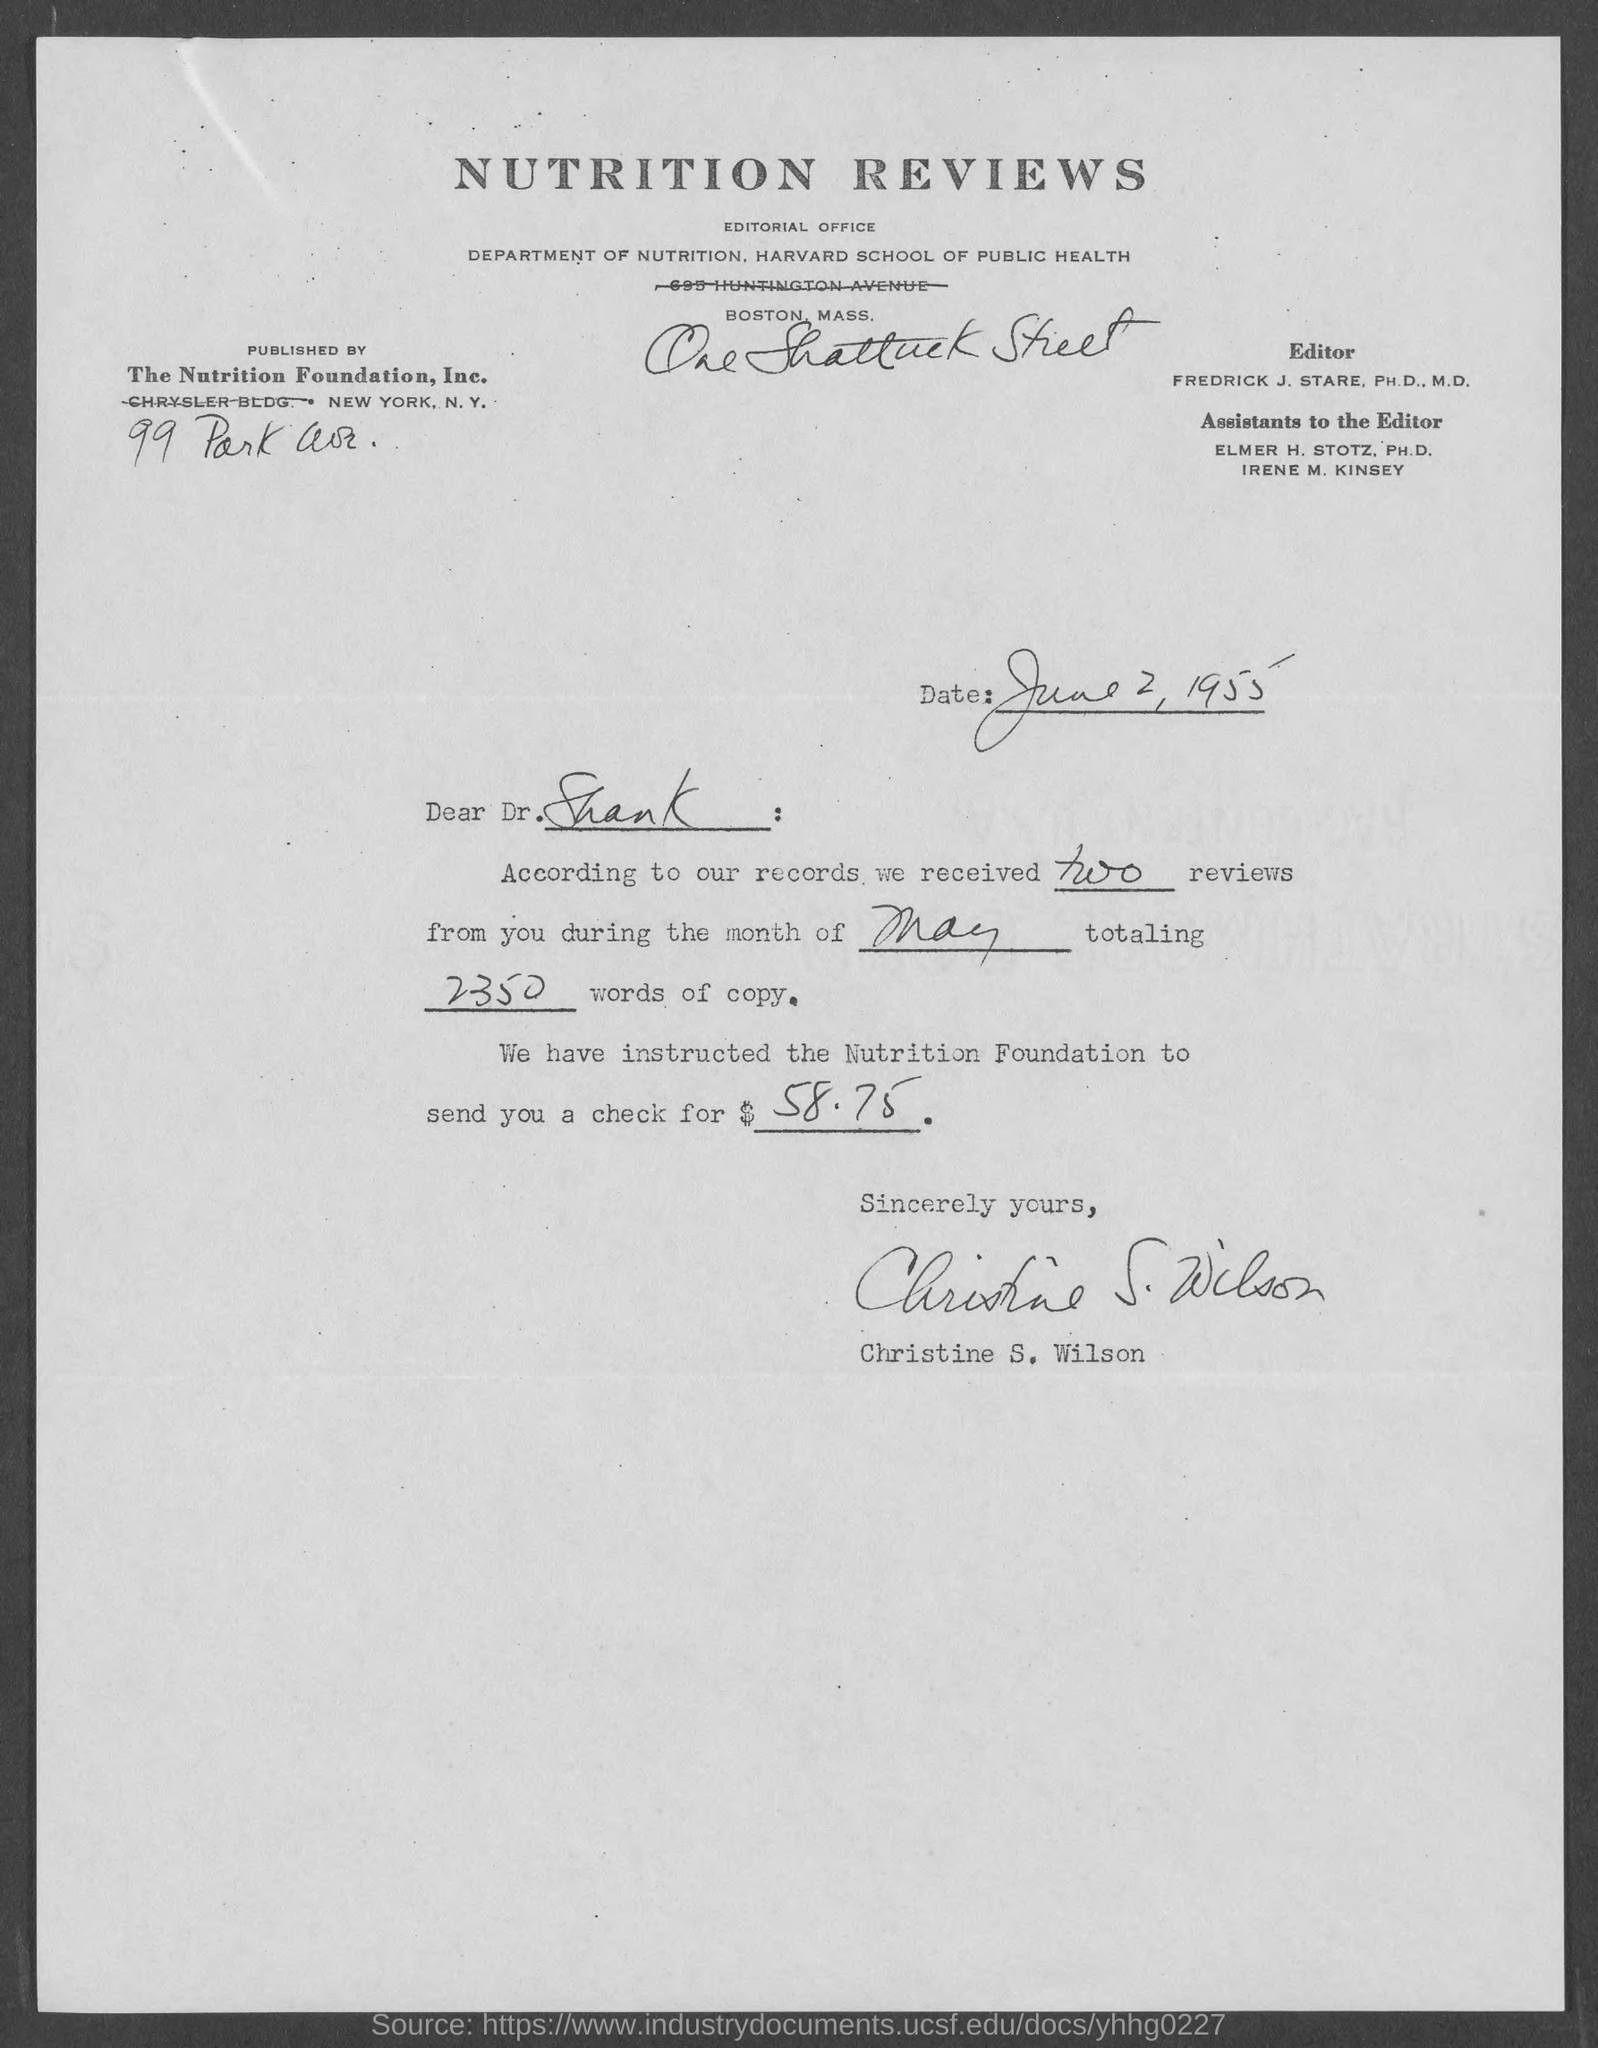What is the date on the document?
Give a very brief answer. June 2, 1955. Who is it published by?
Ensure brevity in your answer.  THE NUTRITION FOUNDATION, INC. To Whom is this letter addressed to?
Provide a succinct answer. Dr. Shank. How many reviews have been received?
Offer a very short reply. Two. For which month have been the reviews for?
Make the answer very short. May. How many words of copy?
Keep it short and to the point. 2350. What is the amount of check?
Your answer should be very brief. $58.75. Who is this letter from?
Give a very brief answer. CHRISTINE S. WILSON. 